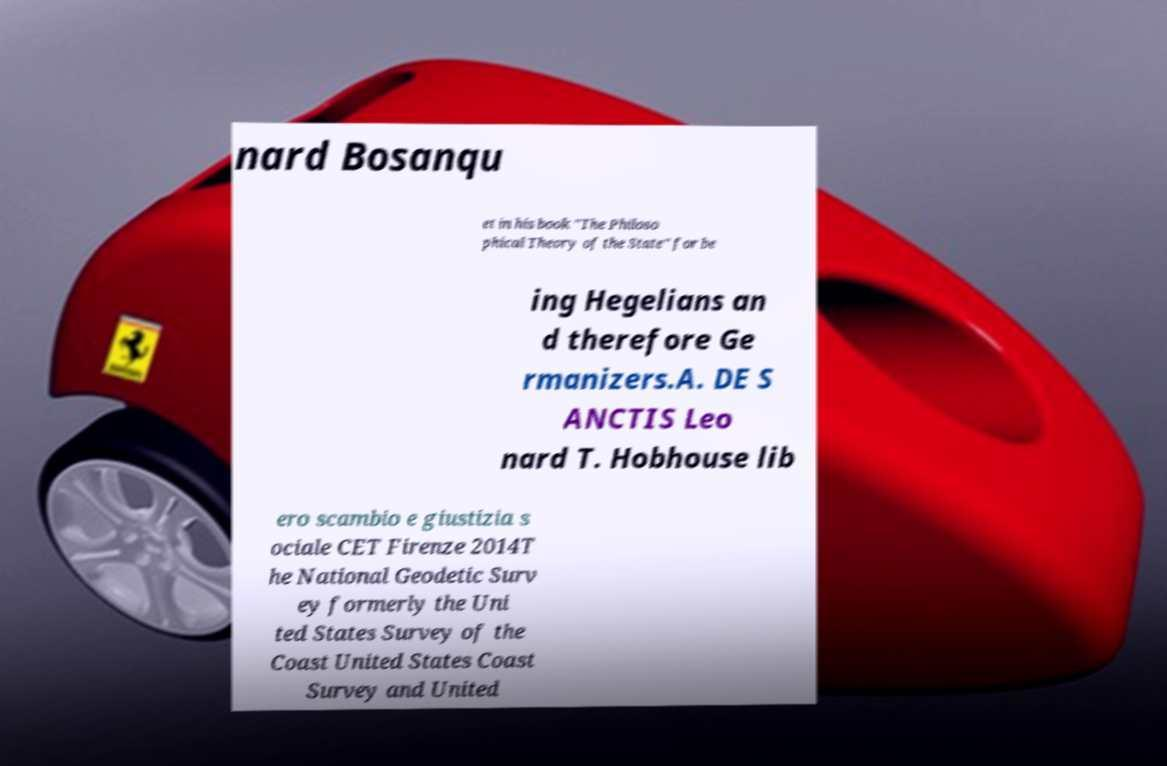Can you accurately transcribe the text from the provided image for me? nard Bosanqu et in his book "The Philoso phical Theory of the State" for be ing Hegelians an d therefore Ge rmanizers.A. DE S ANCTIS Leo nard T. Hobhouse lib ero scambio e giustizia s ociale CET Firenze 2014T he National Geodetic Surv ey formerly the Uni ted States Survey of the Coast United States Coast Survey and United 